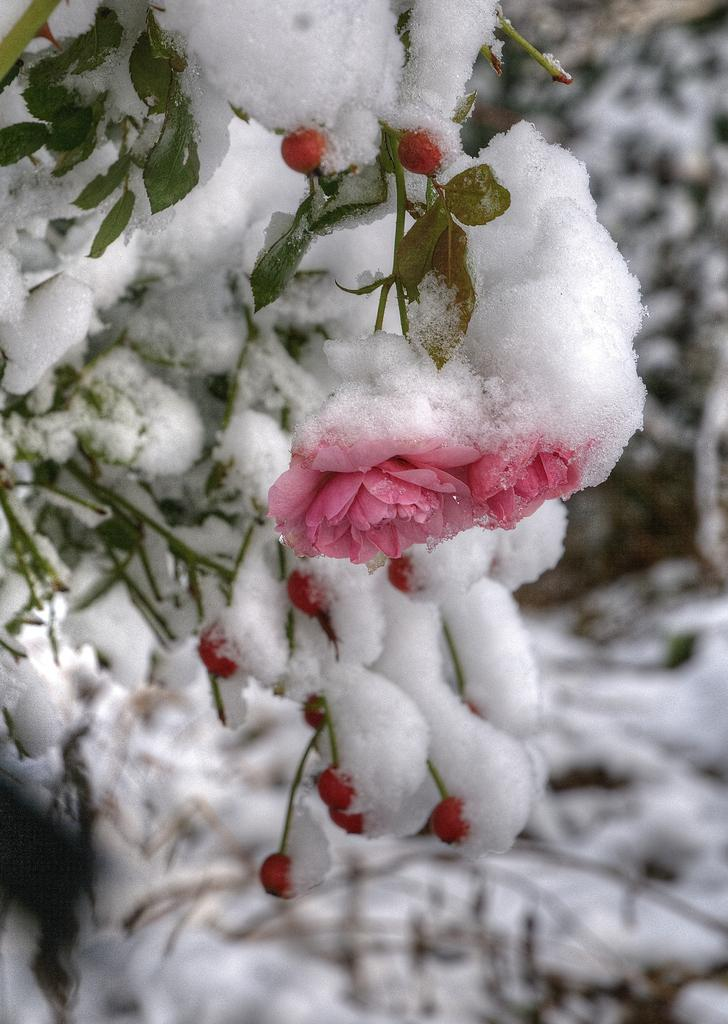What type of vegetation is present on the tree in the image? There are fruits on the tree in the image. Can you describe the environment in the image? The image shows a snowy environment. How many children are playing with the heart in the snowy environment? There are no children or hearts present in the image; it only shows a tree with fruits in a snowy environment. 